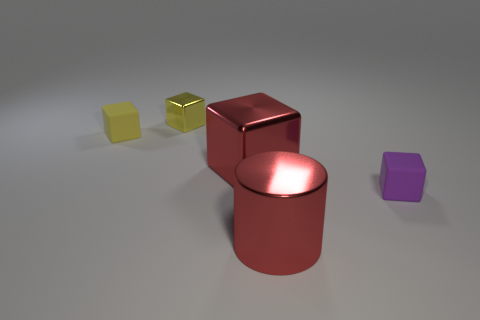Subtract all purple cubes. Subtract all purple balls. How many cubes are left? 3 Add 3 yellow objects. How many objects exist? 8 Subtract all cylinders. How many objects are left? 4 Subtract all big yellow shiny cubes. Subtract all small yellow rubber objects. How many objects are left? 4 Add 4 tiny yellow cubes. How many tiny yellow cubes are left? 6 Add 3 shiny objects. How many shiny objects exist? 6 Subtract 0 brown cylinders. How many objects are left? 5 